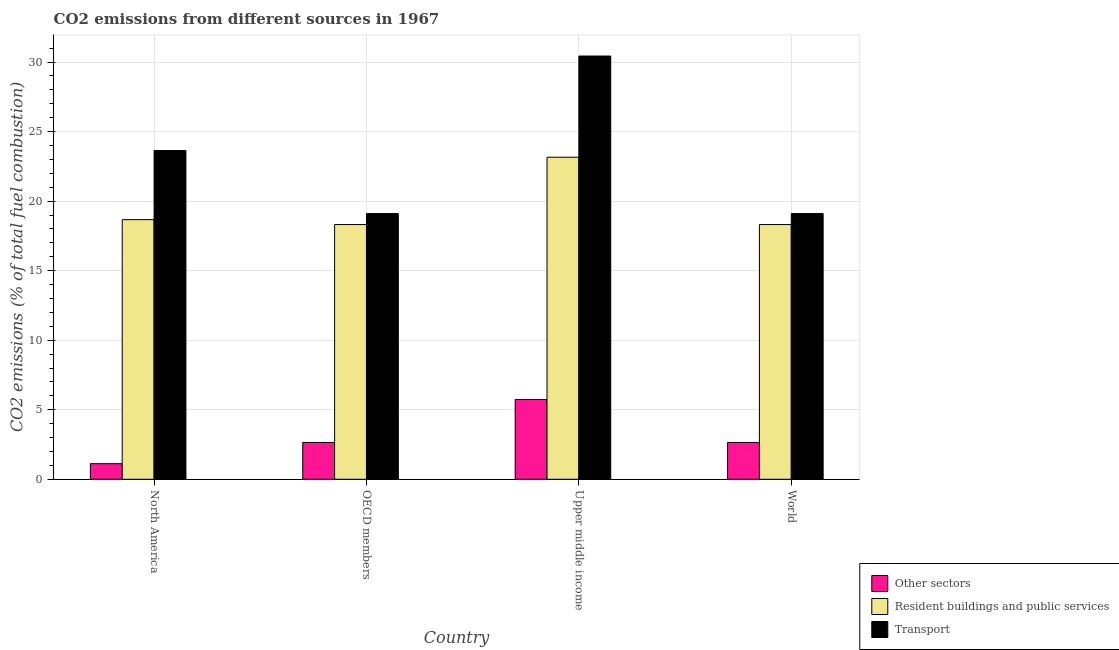How many groups of bars are there?
Provide a short and direct response. 4. How many bars are there on the 3rd tick from the right?
Make the answer very short. 3. What is the label of the 4th group of bars from the left?
Your response must be concise. World. What is the percentage of co2 emissions from transport in World?
Your answer should be compact. 19.1. Across all countries, what is the maximum percentage of co2 emissions from other sectors?
Your answer should be very brief. 5.74. Across all countries, what is the minimum percentage of co2 emissions from resident buildings and public services?
Offer a very short reply. 18.32. In which country was the percentage of co2 emissions from transport maximum?
Offer a very short reply. Upper middle income. In which country was the percentage of co2 emissions from resident buildings and public services minimum?
Your answer should be compact. OECD members. What is the total percentage of co2 emissions from resident buildings and public services in the graph?
Ensure brevity in your answer.  78.45. What is the difference between the percentage of co2 emissions from resident buildings and public services in North America and that in World?
Give a very brief answer. 0.35. What is the difference between the percentage of co2 emissions from transport in OECD members and the percentage of co2 emissions from resident buildings and public services in Upper middle income?
Give a very brief answer. -4.05. What is the average percentage of co2 emissions from resident buildings and public services per country?
Keep it short and to the point. 19.61. What is the difference between the percentage of co2 emissions from resident buildings and public services and percentage of co2 emissions from other sectors in North America?
Provide a short and direct response. 17.55. In how many countries, is the percentage of co2 emissions from other sectors greater than 5 %?
Offer a very short reply. 1. What is the ratio of the percentage of co2 emissions from transport in North America to that in Upper middle income?
Ensure brevity in your answer.  0.78. Is the percentage of co2 emissions from other sectors in OECD members less than that in Upper middle income?
Provide a succinct answer. Yes. What is the difference between the highest and the second highest percentage of co2 emissions from other sectors?
Make the answer very short. 3.09. What is the difference between the highest and the lowest percentage of co2 emissions from resident buildings and public services?
Make the answer very short. 4.84. In how many countries, is the percentage of co2 emissions from resident buildings and public services greater than the average percentage of co2 emissions from resident buildings and public services taken over all countries?
Give a very brief answer. 1. Is the sum of the percentage of co2 emissions from transport in North America and OECD members greater than the maximum percentage of co2 emissions from other sectors across all countries?
Keep it short and to the point. Yes. What does the 2nd bar from the left in Upper middle income represents?
Your answer should be compact. Resident buildings and public services. What does the 1st bar from the right in World represents?
Provide a short and direct response. Transport. Is it the case that in every country, the sum of the percentage of co2 emissions from other sectors and percentage of co2 emissions from resident buildings and public services is greater than the percentage of co2 emissions from transport?
Make the answer very short. No. How many bars are there?
Ensure brevity in your answer.  12. What is the difference between two consecutive major ticks on the Y-axis?
Give a very brief answer. 5. Does the graph contain any zero values?
Provide a succinct answer. No. Where does the legend appear in the graph?
Offer a very short reply. Bottom right. What is the title of the graph?
Give a very brief answer. CO2 emissions from different sources in 1967. Does "Primary" appear as one of the legend labels in the graph?
Provide a succinct answer. No. What is the label or title of the Y-axis?
Offer a very short reply. CO2 emissions (% of total fuel combustion). What is the CO2 emissions (% of total fuel combustion) in Other sectors in North America?
Offer a very short reply. 1.12. What is the CO2 emissions (% of total fuel combustion) in Resident buildings and public services in North America?
Make the answer very short. 18.67. What is the CO2 emissions (% of total fuel combustion) in Transport in North America?
Offer a terse response. 23.64. What is the CO2 emissions (% of total fuel combustion) in Other sectors in OECD members?
Give a very brief answer. 2.65. What is the CO2 emissions (% of total fuel combustion) in Resident buildings and public services in OECD members?
Your answer should be very brief. 18.32. What is the CO2 emissions (% of total fuel combustion) of Transport in OECD members?
Give a very brief answer. 19.1. What is the CO2 emissions (% of total fuel combustion) in Other sectors in Upper middle income?
Provide a short and direct response. 5.74. What is the CO2 emissions (% of total fuel combustion) of Resident buildings and public services in Upper middle income?
Your response must be concise. 23.16. What is the CO2 emissions (% of total fuel combustion) in Transport in Upper middle income?
Provide a short and direct response. 30.43. What is the CO2 emissions (% of total fuel combustion) in Other sectors in World?
Make the answer very short. 2.65. What is the CO2 emissions (% of total fuel combustion) of Resident buildings and public services in World?
Your answer should be compact. 18.32. What is the CO2 emissions (% of total fuel combustion) in Transport in World?
Ensure brevity in your answer.  19.1. Across all countries, what is the maximum CO2 emissions (% of total fuel combustion) of Other sectors?
Provide a succinct answer. 5.74. Across all countries, what is the maximum CO2 emissions (% of total fuel combustion) in Resident buildings and public services?
Offer a very short reply. 23.16. Across all countries, what is the maximum CO2 emissions (% of total fuel combustion) in Transport?
Provide a succinct answer. 30.43. Across all countries, what is the minimum CO2 emissions (% of total fuel combustion) in Other sectors?
Give a very brief answer. 1.12. Across all countries, what is the minimum CO2 emissions (% of total fuel combustion) of Resident buildings and public services?
Your answer should be compact. 18.32. Across all countries, what is the minimum CO2 emissions (% of total fuel combustion) in Transport?
Ensure brevity in your answer.  19.1. What is the total CO2 emissions (% of total fuel combustion) in Other sectors in the graph?
Your answer should be very brief. 12.16. What is the total CO2 emissions (% of total fuel combustion) of Resident buildings and public services in the graph?
Provide a short and direct response. 78.45. What is the total CO2 emissions (% of total fuel combustion) of Transport in the graph?
Provide a short and direct response. 92.28. What is the difference between the CO2 emissions (% of total fuel combustion) of Other sectors in North America and that in OECD members?
Provide a succinct answer. -1.53. What is the difference between the CO2 emissions (% of total fuel combustion) of Resident buildings and public services in North America and that in OECD members?
Your response must be concise. 0.35. What is the difference between the CO2 emissions (% of total fuel combustion) of Transport in North America and that in OECD members?
Your answer should be very brief. 4.53. What is the difference between the CO2 emissions (% of total fuel combustion) of Other sectors in North America and that in Upper middle income?
Offer a terse response. -4.62. What is the difference between the CO2 emissions (% of total fuel combustion) in Resident buildings and public services in North America and that in Upper middle income?
Ensure brevity in your answer.  -4.49. What is the difference between the CO2 emissions (% of total fuel combustion) of Transport in North America and that in Upper middle income?
Offer a very short reply. -6.79. What is the difference between the CO2 emissions (% of total fuel combustion) in Other sectors in North America and that in World?
Ensure brevity in your answer.  -1.53. What is the difference between the CO2 emissions (% of total fuel combustion) in Resident buildings and public services in North America and that in World?
Your response must be concise. 0.35. What is the difference between the CO2 emissions (% of total fuel combustion) in Transport in North America and that in World?
Give a very brief answer. 4.53. What is the difference between the CO2 emissions (% of total fuel combustion) in Other sectors in OECD members and that in Upper middle income?
Your answer should be compact. -3.09. What is the difference between the CO2 emissions (% of total fuel combustion) in Resident buildings and public services in OECD members and that in Upper middle income?
Your answer should be very brief. -4.84. What is the difference between the CO2 emissions (% of total fuel combustion) in Transport in OECD members and that in Upper middle income?
Keep it short and to the point. -11.33. What is the difference between the CO2 emissions (% of total fuel combustion) of Other sectors in OECD members and that in World?
Ensure brevity in your answer.  0. What is the difference between the CO2 emissions (% of total fuel combustion) in Transport in OECD members and that in World?
Your response must be concise. 0. What is the difference between the CO2 emissions (% of total fuel combustion) of Other sectors in Upper middle income and that in World?
Give a very brief answer. 3.09. What is the difference between the CO2 emissions (% of total fuel combustion) of Resident buildings and public services in Upper middle income and that in World?
Your answer should be compact. 4.84. What is the difference between the CO2 emissions (% of total fuel combustion) of Transport in Upper middle income and that in World?
Your answer should be very brief. 11.33. What is the difference between the CO2 emissions (% of total fuel combustion) of Other sectors in North America and the CO2 emissions (% of total fuel combustion) of Resident buildings and public services in OECD members?
Provide a succinct answer. -17.19. What is the difference between the CO2 emissions (% of total fuel combustion) of Other sectors in North America and the CO2 emissions (% of total fuel combustion) of Transport in OECD members?
Keep it short and to the point. -17.98. What is the difference between the CO2 emissions (% of total fuel combustion) of Resident buildings and public services in North America and the CO2 emissions (% of total fuel combustion) of Transport in OECD members?
Ensure brevity in your answer.  -0.44. What is the difference between the CO2 emissions (% of total fuel combustion) in Other sectors in North America and the CO2 emissions (% of total fuel combustion) in Resident buildings and public services in Upper middle income?
Provide a short and direct response. -22.03. What is the difference between the CO2 emissions (% of total fuel combustion) in Other sectors in North America and the CO2 emissions (% of total fuel combustion) in Transport in Upper middle income?
Keep it short and to the point. -29.31. What is the difference between the CO2 emissions (% of total fuel combustion) of Resident buildings and public services in North America and the CO2 emissions (% of total fuel combustion) of Transport in Upper middle income?
Give a very brief answer. -11.76. What is the difference between the CO2 emissions (% of total fuel combustion) in Other sectors in North America and the CO2 emissions (% of total fuel combustion) in Resident buildings and public services in World?
Keep it short and to the point. -17.19. What is the difference between the CO2 emissions (% of total fuel combustion) in Other sectors in North America and the CO2 emissions (% of total fuel combustion) in Transport in World?
Keep it short and to the point. -17.98. What is the difference between the CO2 emissions (% of total fuel combustion) in Resident buildings and public services in North America and the CO2 emissions (% of total fuel combustion) in Transport in World?
Offer a very short reply. -0.44. What is the difference between the CO2 emissions (% of total fuel combustion) of Other sectors in OECD members and the CO2 emissions (% of total fuel combustion) of Resident buildings and public services in Upper middle income?
Your answer should be very brief. -20.51. What is the difference between the CO2 emissions (% of total fuel combustion) of Other sectors in OECD members and the CO2 emissions (% of total fuel combustion) of Transport in Upper middle income?
Offer a terse response. -27.78. What is the difference between the CO2 emissions (% of total fuel combustion) of Resident buildings and public services in OECD members and the CO2 emissions (% of total fuel combustion) of Transport in Upper middle income?
Your answer should be compact. -12.11. What is the difference between the CO2 emissions (% of total fuel combustion) of Other sectors in OECD members and the CO2 emissions (% of total fuel combustion) of Resident buildings and public services in World?
Your answer should be very brief. -15.67. What is the difference between the CO2 emissions (% of total fuel combustion) of Other sectors in OECD members and the CO2 emissions (% of total fuel combustion) of Transport in World?
Your answer should be compact. -16.46. What is the difference between the CO2 emissions (% of total fuel combustion) in Resident buildings and public services in OECD members and the CO2 emissions (% of total fuel combustion) in Transport in World?
Provide a short and direct response. -0.79. What is the difference between the CO2 emissions (% of total fuel combustion) of Other sectors in Upper middle income and the CO2 emissions (% of total fuel combustion) of Resident buildings and public services in World?
Offer a very short reply. -12.58. What is the difference between the CO2 emissions (% of total fuel combustion) in Other sectors in Upper middle income and the CO2 emissions (% of total fuel combustion) in Transport in World?
Keep it short and to the point. -13.37. What is the difference between the CO2 emissions (% of total fuel combustion) in Resident buildings and public services in Upper middle income and the CO2 emissions (% of total fuel combustion) in Transport in World?
Keep it short and to the point. 4.05. What is the average CO2 emissions (% of total fuel combustion) in Other sectors per country?
Offer a very short reply. 3.04. What is the average CO2 emissions (% of total fuel combustion) of Resident buildings and public services per country?
Your response must be concise. 19.61. What is the average CO2 emissions (% of total fuel combustion) in Transport per country?
Your answer should be compact. 23.07. What is the difference between the CO2 emissions (% of total fuel combustion) of Other sectors and CO2 emissions (% of total fuel combustion) of Resident buildings and public services in North America?
Your answer should be compact. -17.55. What is the difference between the CO2 emissions (% of total fuel combustion) in Other sectors and CO2 emissions (% of total fuel combustion) in Transport in North America?
Offer a very short reply. -22.51. What is the difference between the CO2 emissions (% of total fuel combustion) of Resident buildings and public services and CO2 emissions (% of total fuel combustion) of Transport in North America?
Give a very brief answer. -4.97. What is the difference between the CO2 emissions (% of total fuel combustion) of Other sectors and CO2 emissions (% of total fuel combustion) of Resident buildings and public services in OECD members?
Provide a short and direct response. -15.67. What is the difference between the CO2 emissions (% of total fuel combustion) in Other sectors and CO2 emissions (% of total fuel combustion) in Transport in OECD members?
Your response must be concise. -16.46. What is the difference between the CO2 emissions (% of total fuel combustion) in Resident buildings and public services and CO2 emissions (% of total fuel combustion) in Transport in OECD members?
Give a very brief answer. -0.79. What is the difference between the CO2 emissions (% of total fuel combustion) in Other sectors and CO2 emissions (% of total fuel combustion) in Resident buildings and public services in Upper middle income?
Offer a very short reply. -17.42. What is the difference between the CO2 emissions (% of total fuel combustion) of Other sectors and CO2 emissions (% of total fuel combustion) of Transport in Upper middle income?
Give a very brief answer. -24.69. What is the difference between the CO2 emissions (% of total fuel combustion) of Resident buildings and public services and CO2 emissions (% of total fuel combustion) of Transport in Upper middle income?
Offer a terse response. -7.27. What is the difference between the CO2 emissions (% of total fuel combustion) of Other sectors and CO2 emissions (% of total fuel combustion) of Resident buildings and public services in World?
Ensure brevity in your answer.  -15.67. What is the difference between the CO2 emissions (% of total fuel combustion) of Other sectors and CO2 emissions (% of total fuel combustion) of Transport in World?
Your answer should be compact. -16.46. What is the difference between the CO2 emissions (% of total fuel combustion) in Resident buildings and public services and CO2 emissions (% of total fuel combustion) in Transport in World?
Your answer should be compact. -0.79. What is the ratio of the CO2 emissions (% of total fuel combustion) in Other sectors in North America to that in OECD members?
Make the answer very short. 0.42. What is the ratio of the CO2 emissions (% of total fuel combustion) of Resident buildings and public services in North America to that in OECD members?
Your answer should be compact. 1.02. What is the ratio of the CO2 emissions (% of total fuel combustion) of Transport in North America to that in OECD members?
Your response must be concise. 1.24. What is the ratio of the CO2 emissions (% of total fuel combustion) of Other sectors in North America to that in Upper middle income?
Keep it short and to the point. 0.2. What is the ratio of the CO2 emissions (% of total fuel combustion) of Resident buildings and public services in North America to that in Upper middle income?
Your answer should be compact. 0.81. What is the ratio of the CO2 emissions (% of total fuel combustion) in Transport in North America to that in Upper middle income?
Your answer should be compact. 0.78. What is the ratio of the CO2 emissions (% of total fuel combustion) in Other sectors in North America to that in World?
Make the answer very short. 0.42. What is the ratio of the CO2 emissions (% of total fuel combustion) in Resident buildings and public services in North America to that in World?
Offer a very short reply. 1.02. What is the ratio of the CO2 emissions (% of total fuel combustion) of Transport in North America to that in World?
Your answer should be compact. 1.24. What is the ratio of the CO2 emissions (% of total fuel combustion) in Other sectors in OECD members to that in Upper middle income?
Offer a terse response. 0.46. What is the ratio of the CO2 emissions (% of total fuel combustion) in Resident buildings and public services in OECD members to that in Upper middle income?
Ensure brevity in your answer.  0.79. What is the ratio of the CO2 emissions (% of total fuel combustion) of Transport in OECD members to that in Upper middle income?
Ensure brevity in your answer.  0.63. What is the ratio of the CO2 emissions (% of total fuel combustion) of Other sectors in OECD members to that in World?
Offer a very short reply. 1. What is the ratio of the CO2 emissions (% of total fuel combustion) of Other sectors in Upper middle income to that in World?
Make the answer very short. 2.17. What is the ratio of the CO2 emissions (% of total fuel combustion) of Resident buildings and public services in Upper middle income to that in World?
Offer a very short reply. 1.26. What is the ratio of the CO2 emissions (% of total fuel combustion) of Transport in Upper middle income to that in World?
Give a very brief answer. 1.59. What is the difference between the highest and the second highest CO2 emissions (% of total fuel combustion) in Other sectors?
Your answer should be compact. 3.09. What is the difference between the highest and the second highest CO2 emissions (% of total fuel combustion) in Resident buildings and public services?
Keep it short and to the point. 4.49. What is the difference between the highest and the second highest CO2 emissions (% of total fuel combustion) of Transport?
Offer a very short reply. 6.79. What is the difference between the highest and the lowest CO2 emissions (% of total fuel combustion) of Other sectors?
Keep it short and to the point. 4.62. What is the difference between the highest and the lowest CO2 emissions (% of total fuel combustion) in Resident buildings and public services?
Ensure brevity in your answer.  4.84. What is the difference between the highest and the lowest CO2 emissions (% of total fuel combustion) of Transport?
Keep it short and to the point. 11.33. 